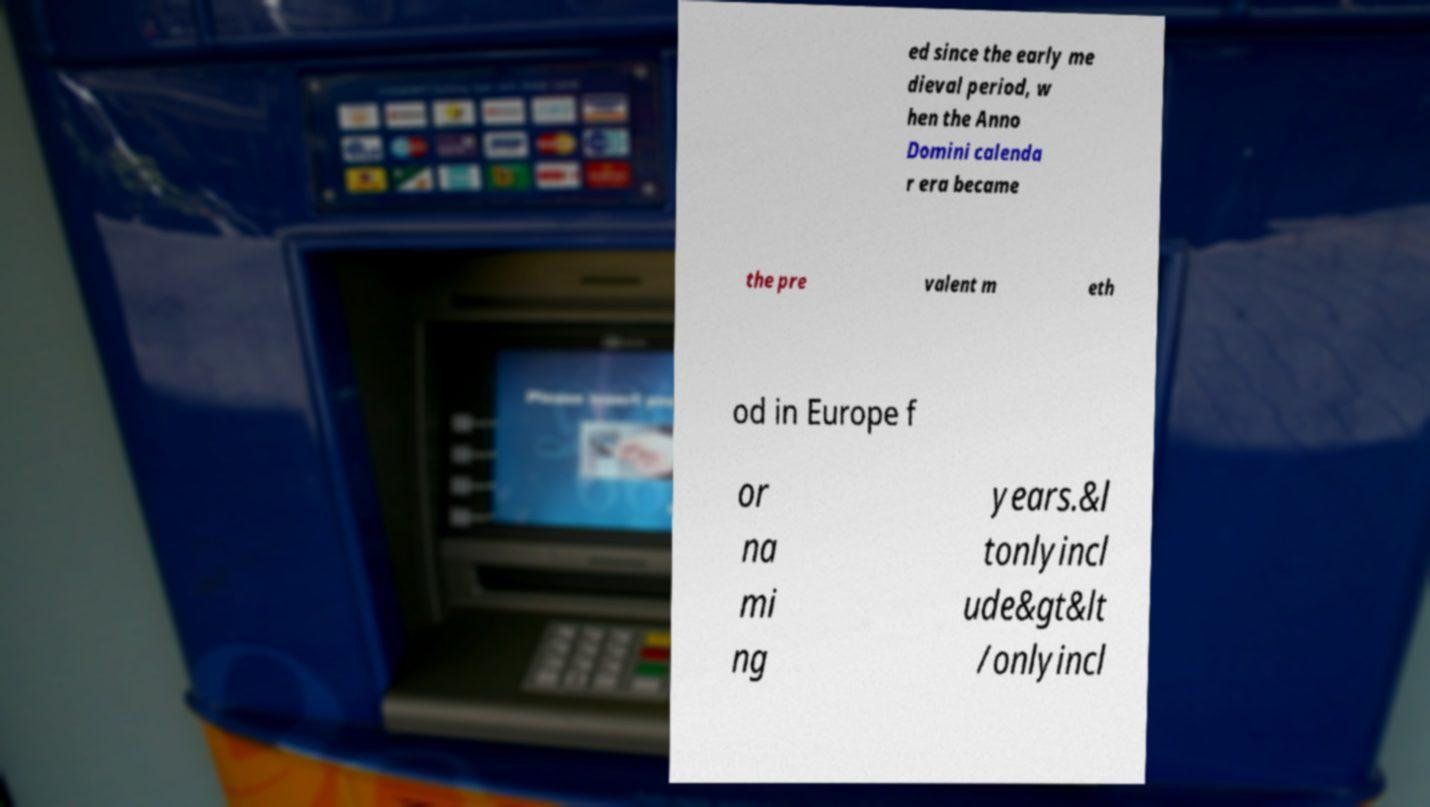Can you read and provide the text displayed in the image?This photo seems to have some interesting text. Can you extract and type it out for me? ed since the early me dieval period, w hen the Anno Domini calenda r era became the pre valent m eth od in Europe f or na mi ng years.&l tonlyincl ude&gt&lt /onlyincl 